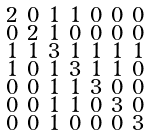<formula> <loc_0><loc_0><loc_500><loc_500>\begin{smallmatrix} 2 & 0 & 1 & 1 & 0 & 0 & 0 \\ 0 & 2 & 1 & 0 & 0 & 0 & 0 \\ 1 & 1 & 3 & 1 & 1 & 1 & 1 \\ 1 & 0 & 1 & 3 & 1 & 1 & 0 \\ 0 & 0 & 1 & 1 & 3 & 0 & 0 \\ 0 & 0 & 1 & 1 & 0 & 3 & 0 \\ 0 & 0 & 1 & 0 & 0 & 0 & 3 \end{smallmatrix}</formula> 